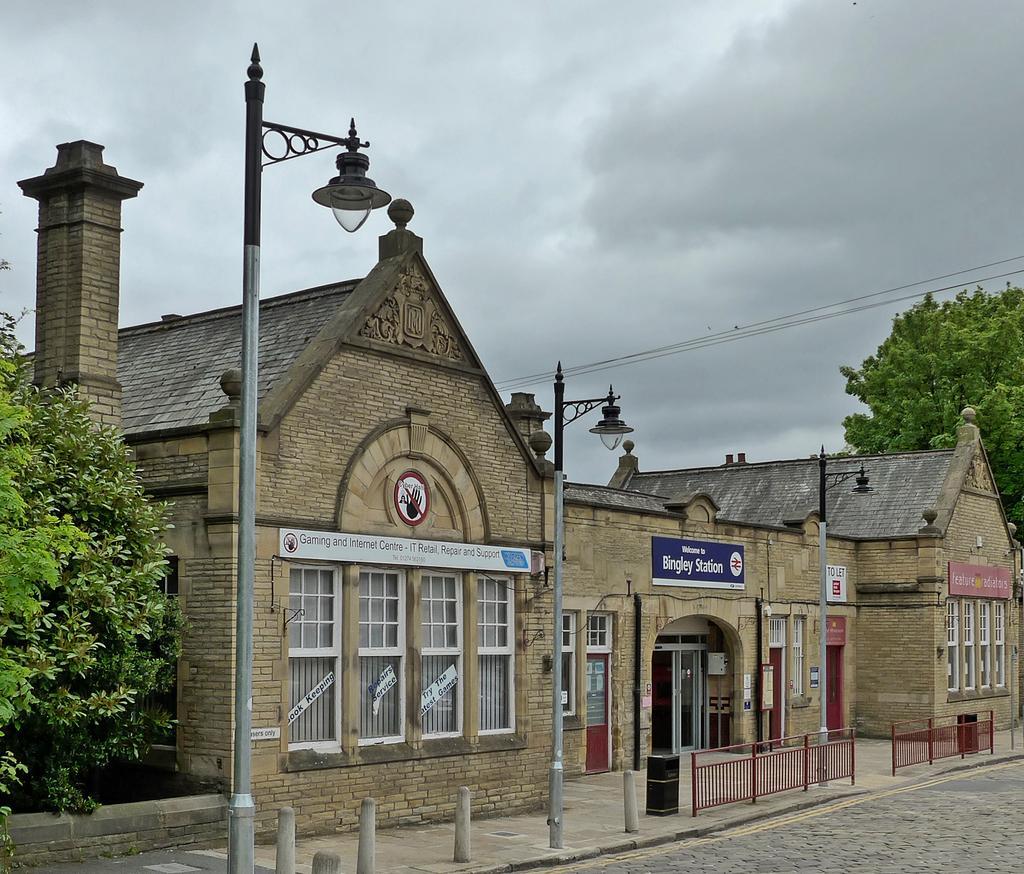Describe this image in one or two sentences. In this picture we can see buildings with windows, fence, poles, trees, wires, name boards, road and in the background we can see the sky with clouds. 